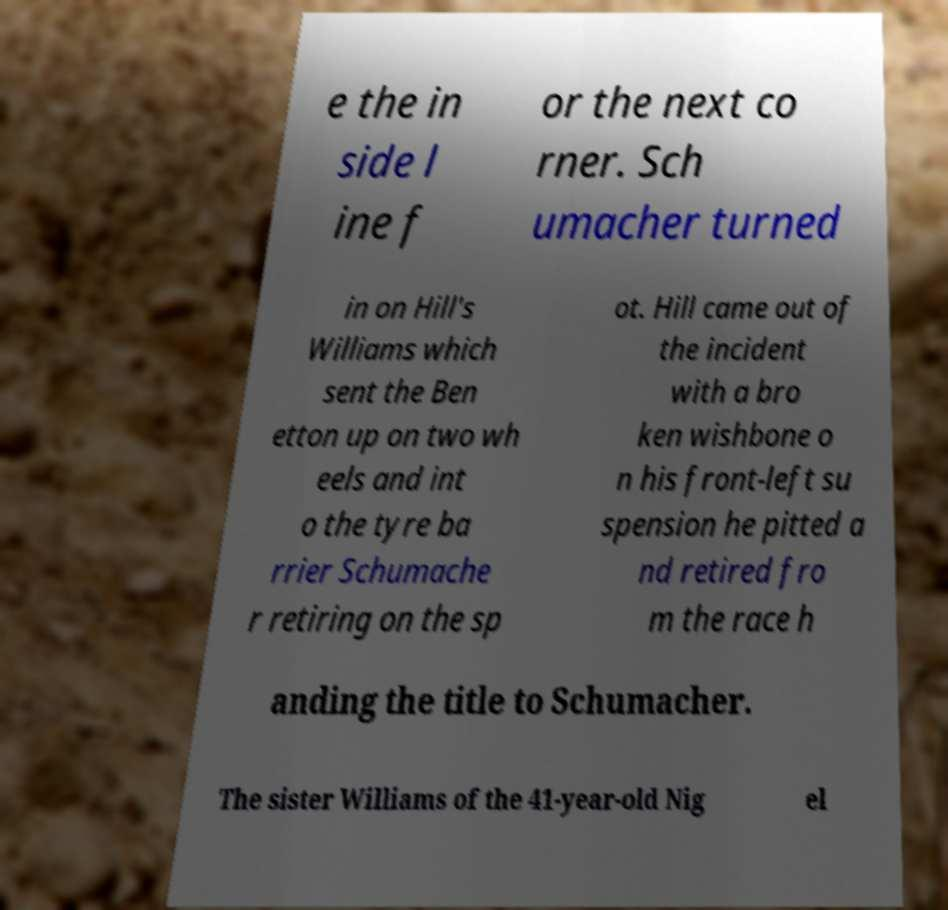Could you extract and type out the text from this image? e the in side l ine f or the next co rner. Sch umacher turned in on Hill's Williams which sent the Ben etton up on two wh eels and int o the tyre ba rrier Schumache r retiring on the sp ot. Hill came out of the incident with a bro ken wishbone o n his front-left su spension he pitted a nd retired fro m the race h anding the title to Schumacher. The sister Williams of the 41-year-old Nig el 